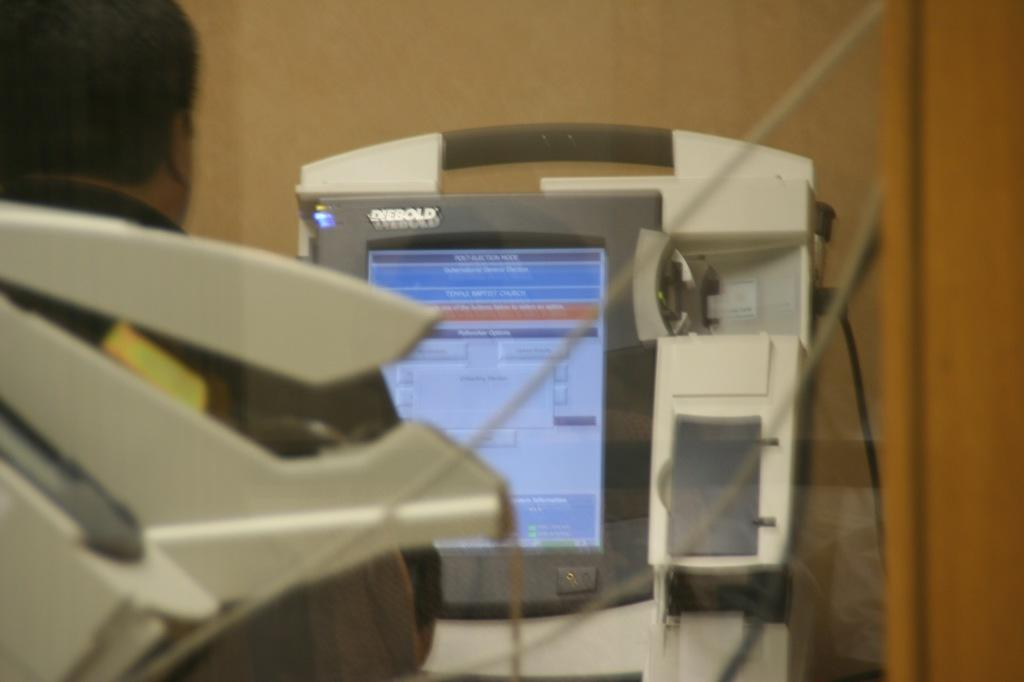What is the main object in the center of the image? There is a device in the center of the image. Can you describe the person's position in the image? There is a person towards the left side of the image. What type of furniture is being used as a guide by the person in the image? There is no furniture present in the image, and the person is not using any guide. 